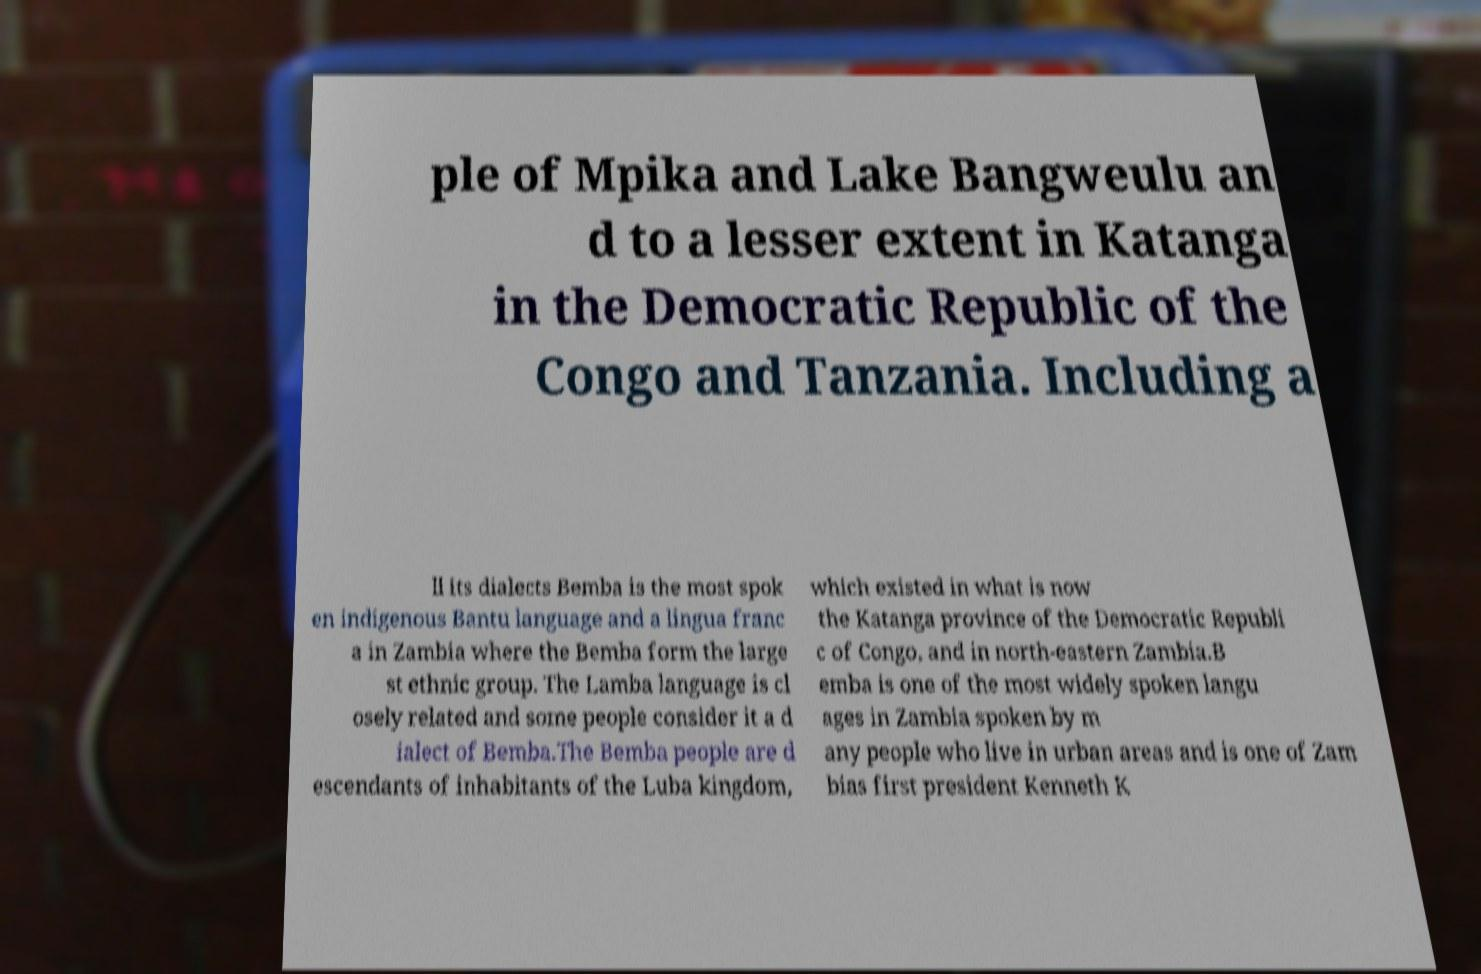Could you assist in decoding the text presented in this image and type it out clearly? ple of Mpika and Lake Bangweulu an d to a lesser extent in Katanga in the Democratic Republic of the Congo and Tanzania. Including a ll its dialects Bemba is the most spok en indigenous Bantu language and a lingua franc a in Zambia where the Bemba form the large st ethnic group. The Lamba language is cl osely related and some people consider it a d ialect of Bemba.The Bemba people are d escendants of inhabitants of the Luba kingdom, which existed in what is now the Katanga province of the Democratic Republi c of Congo, and in north-eastern Zambia.B emba is one of the most widely spoken langu ages in Zambia spoken by m any people who live in urban areas and is one of Zam bias first president Kenneth K 